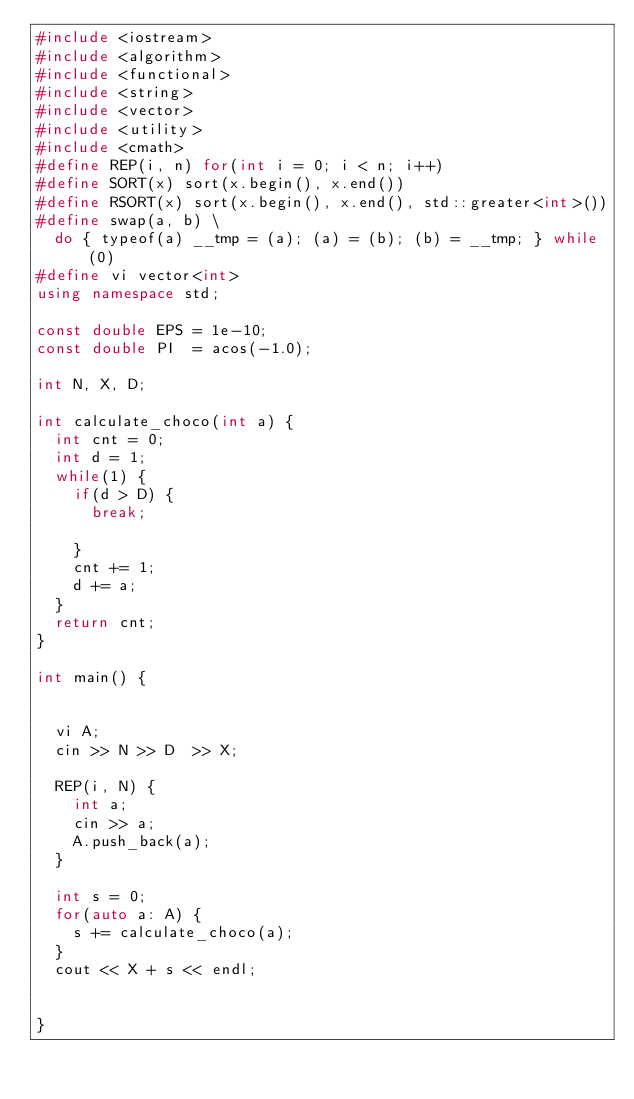Convert code to text. <code><loc_0><loc_0><loc_500><loc_500><_C++_>#include <iostream>
#include <algorithm>
#include <functional>
#include <string>
#include <vector>
#include <utility>
#include <cmath>
#define REP(i, n) for(int i = 0; i < n; i++)
#define SORT(x) sort(x.begin(), x.end())
#define RSORT(x) sort(x.begin(), x.end(), std::greater<int>())
#define swap(a, b) \
  do { typeof(a) __tmp = (a); (a) = (b); (b) = __tmp; } while (0)
#define vi vector<int>
using namespace std;

const double EPS = 1e-10;
const double PI  = acos(-1.0);

int N, X, D;

int calculate_choco(int a) {
  int cnt = 0;
  int d = 1;
  while(1) {
    if(d > D) {
      break;

    }
    cnt += 1;
    d += a;
  }
  return cnt;
}

int main() {

  
  vi A;
  cin >> N >> D  >> X;
  
  REP(i, N) {
    int a;
    cin >> a;
    A.push_back(a);
  }

  int s = 0;
  for(auto a: A) {
    s += calculate_choco(a);
  }
  cout << X + s << endl;

  
}
</code> 